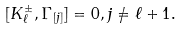<formula> <loc_0><loc_0><loc_500><loc_500>[ K _ { \ell } ^ { \pm } , \Gamma _ { [ j ] } ] = 0 , j \neq \ell + 1 .</formula> 